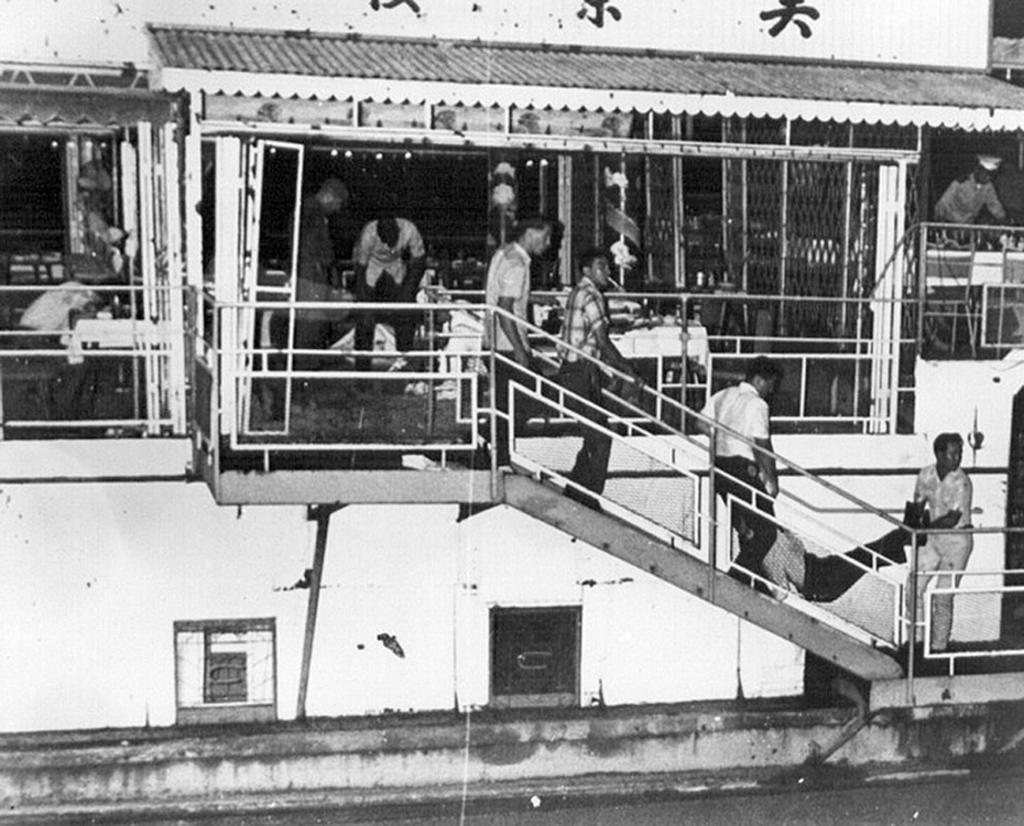Who or what can be seen in the image? There are people in the image. What can be used for support or safety in the image? There are railings in the image. What allows light to enter the space in the image? There are windows in the image. What provides a barrier or separation in the image? There is a wall in the image. What else is present in the image besides the people, railings, windows, and wall? There are objects in the image. What type of calendar is hanging on the wall in the image? There is no calendar present in the image. What beliefs do the people in the image hold? The image does not provide any information about the beliefs of the people in the image. 